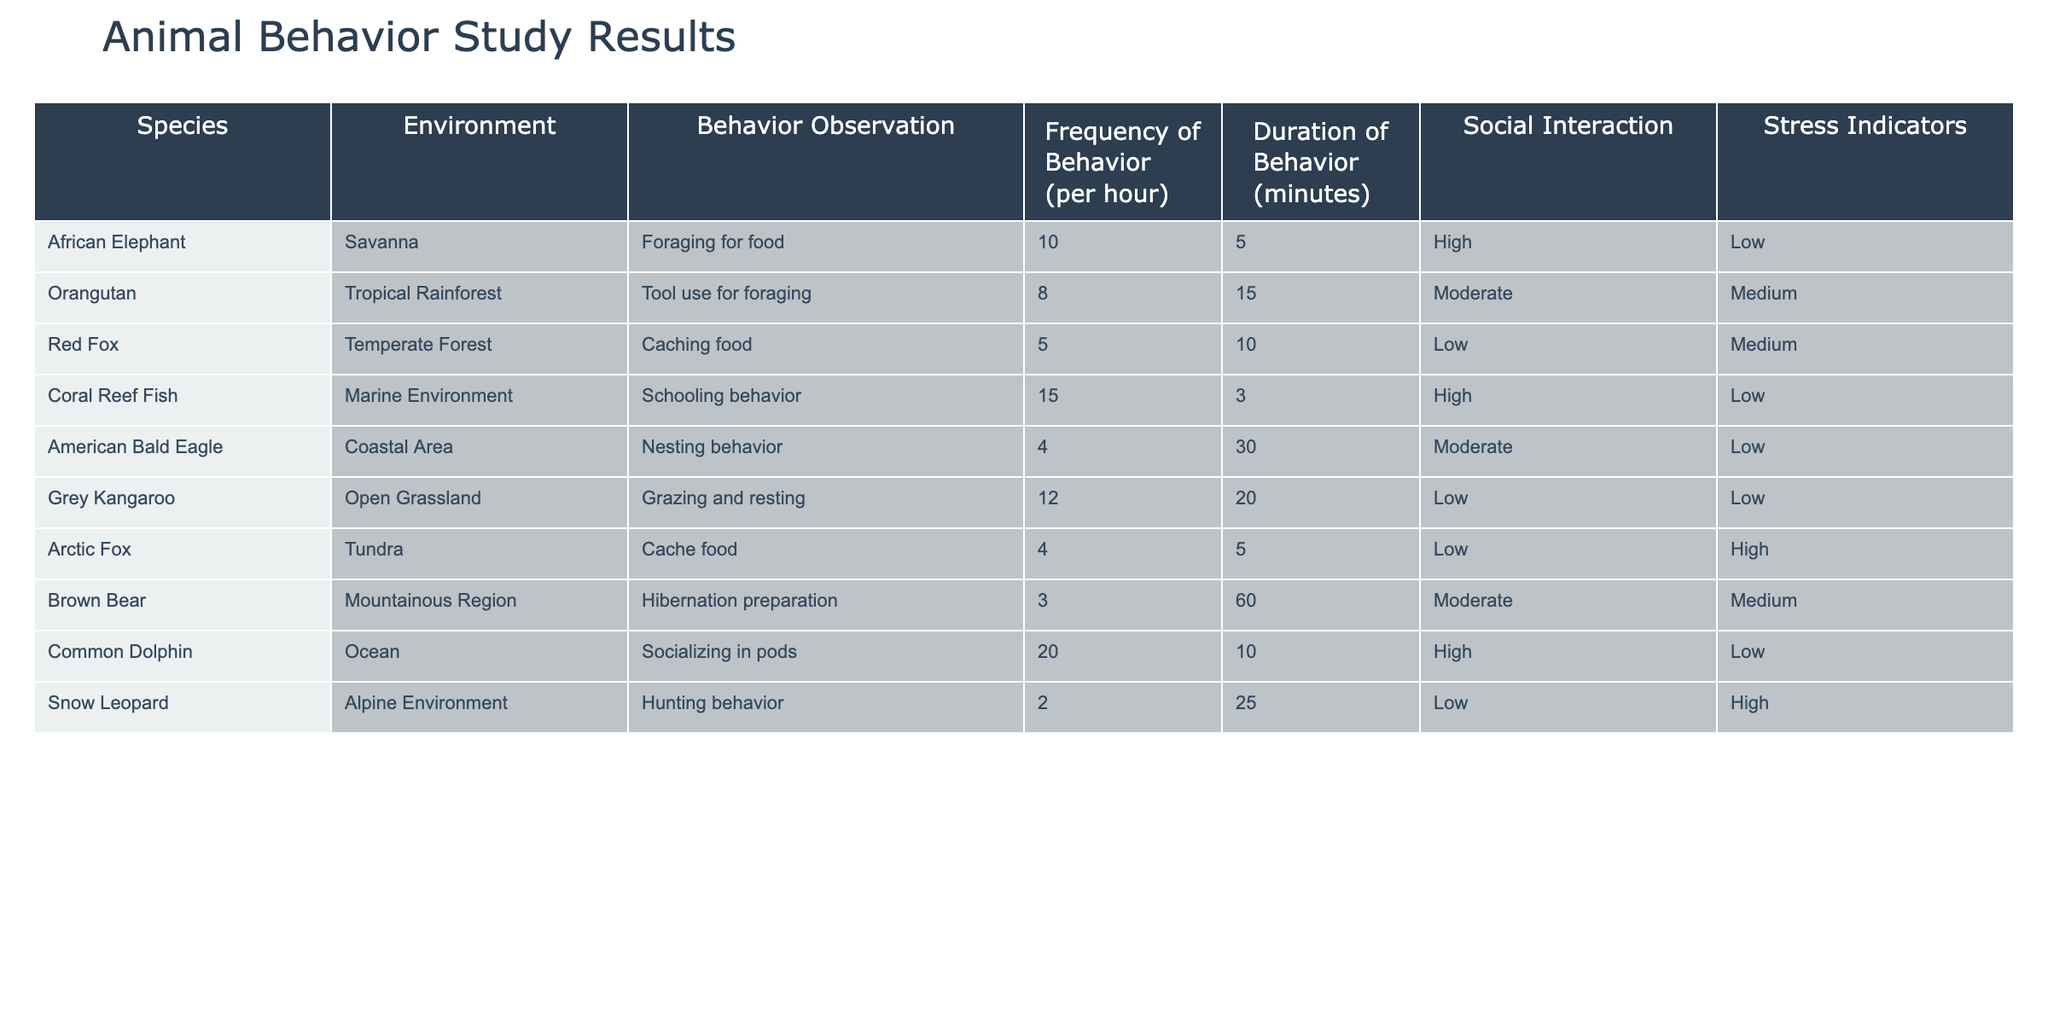What behavior is observed most frequently in Coral Reef Fish? The behavior observed most frequently is schooling behavior, with a frequency of 15 per hour, as indicated in the table.
Answer: Schooling behavior Which species has the highest frequency of social interaction? Common Dolphin has the highest frequency of social interaction, noted as high, performing socializing in pods 20 times per hour.
Answer: Common Dolphin What is the average duration of behavior for the Orangutan in minutes? The Orangutan has a duration of behavior for tool use for foraging lasting 15 minutes, and since this is the only entry for the species, the average is simply 15 minutes.
Answer: 15 Is the Arctic Fox shown to have low stress indicators? No, the Arctic Fox has high stress indicators noted in the table, indicating it experiences more stress compared to other species.
Answer: No Calculate the total frequency of behavior observed across all species under the Tropical Rainforest environment. Only the Orangutan is observed under the Tropical Rainforest environment with a frequency of 8 per hour, leading to a total of 8 for that environment.
Answer: 8 Which species shows a behavior duration of 60 minutes, and what is the behavior? The Brown Bear shows a behavior duration of 60 minutes for hibernation preparation. This is the only entry with a duration of 60 minutes.
Answer: Brown Bear, Hibernation preparation Are there any species that exhibit low stress indicators with a behavior frequency greater than 5? Yes, both Coral Reef Fish (15 times per hour) and Grey Kangaroo (12 times per hour) exhibit low stress indicators while displaying behavior frequencies greater than 5 per hour.
Answer: Yes What is the difference in frequency of behavior between the Common Dolphin and the Snow Leopard? The Common Dolphin exhibits a frequency of 20 while the Snow Leopard exhibits a frequency of 2. The difference is calculated as 20 - 2 = 18.
Answer: 18 Which species has the lowest frequency of behavior, and what is the behavior? The Snow Leopard has the lowest frequency of behavior at 2 per hour for hunting behavior.
Answer: Snow Leopard, Hunting behavior 